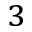Convert formula to latex. <formula><loc_0><loc_0><loc_500><loc_500>_ { 3 }</formula> 